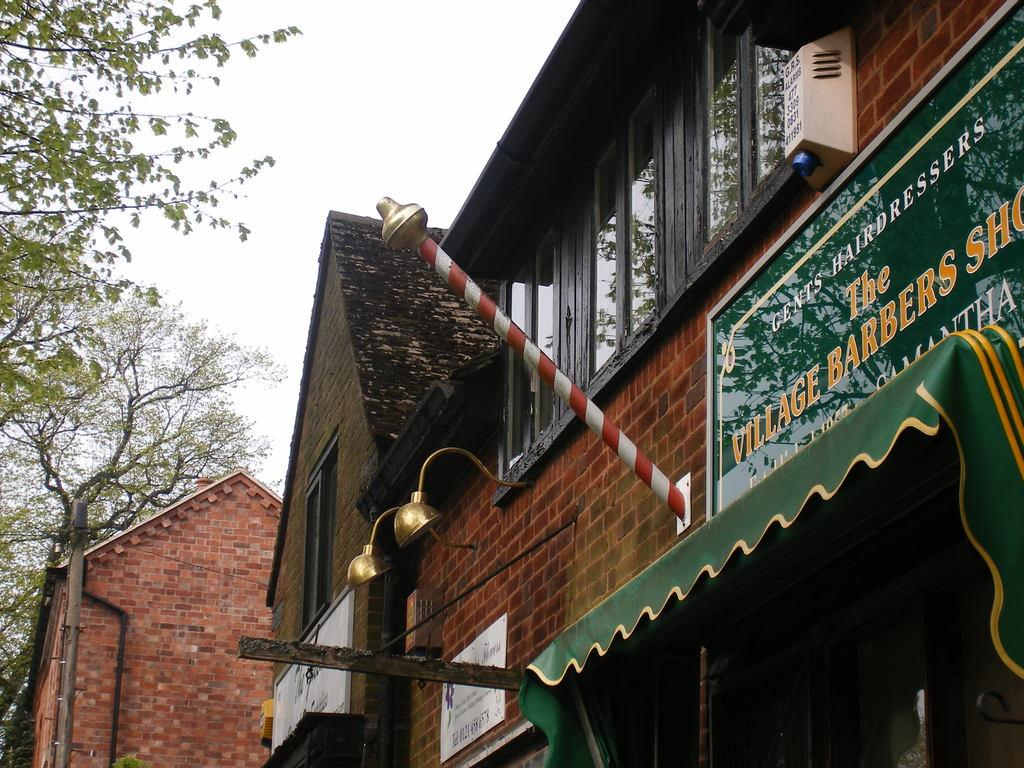What type of establishments can be seen in the image? There are shops in the image. What is written or displayed on a board in the image? There is a board with text on it. What type of vegetation is on the left side of the image? There are trees on the left side of the image. What is visible at the top of the image? The sky is visible at the top of the image. Where is the hammer being used in the image? There is no hammer present in the image. How many apples are hanging from the trees on the left side of the image? There are no apples visible in the image, as it only shows trees. 